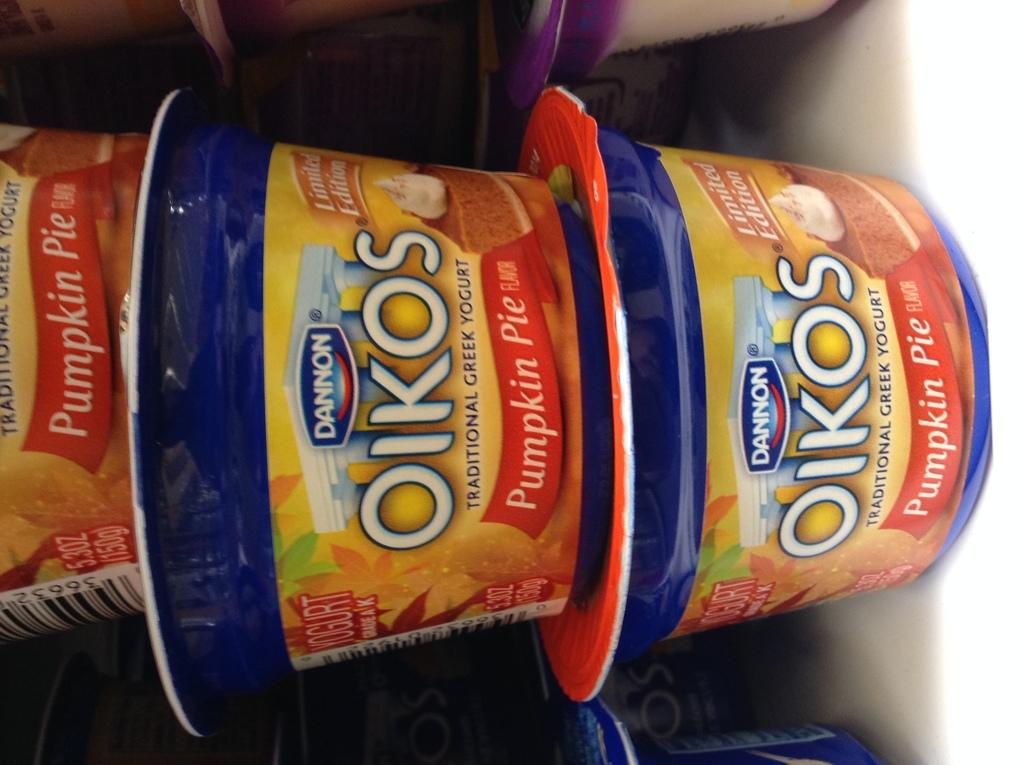What type of food items are present in the racks in the image? There are yogurt cups present in the racks. How are the yogurt cups arranged in the racks? The provided facts do not mention the arrangement of the yogurt cups in the racks. What type of company is associated with the yogurt cups in the image? The provided facts do not mention any company associated with the yogurt cups. Can you see a pickle or a rat in the image? There is no mention of a pickle or a rat in the provided facts, so they cannot be seen in the image. 